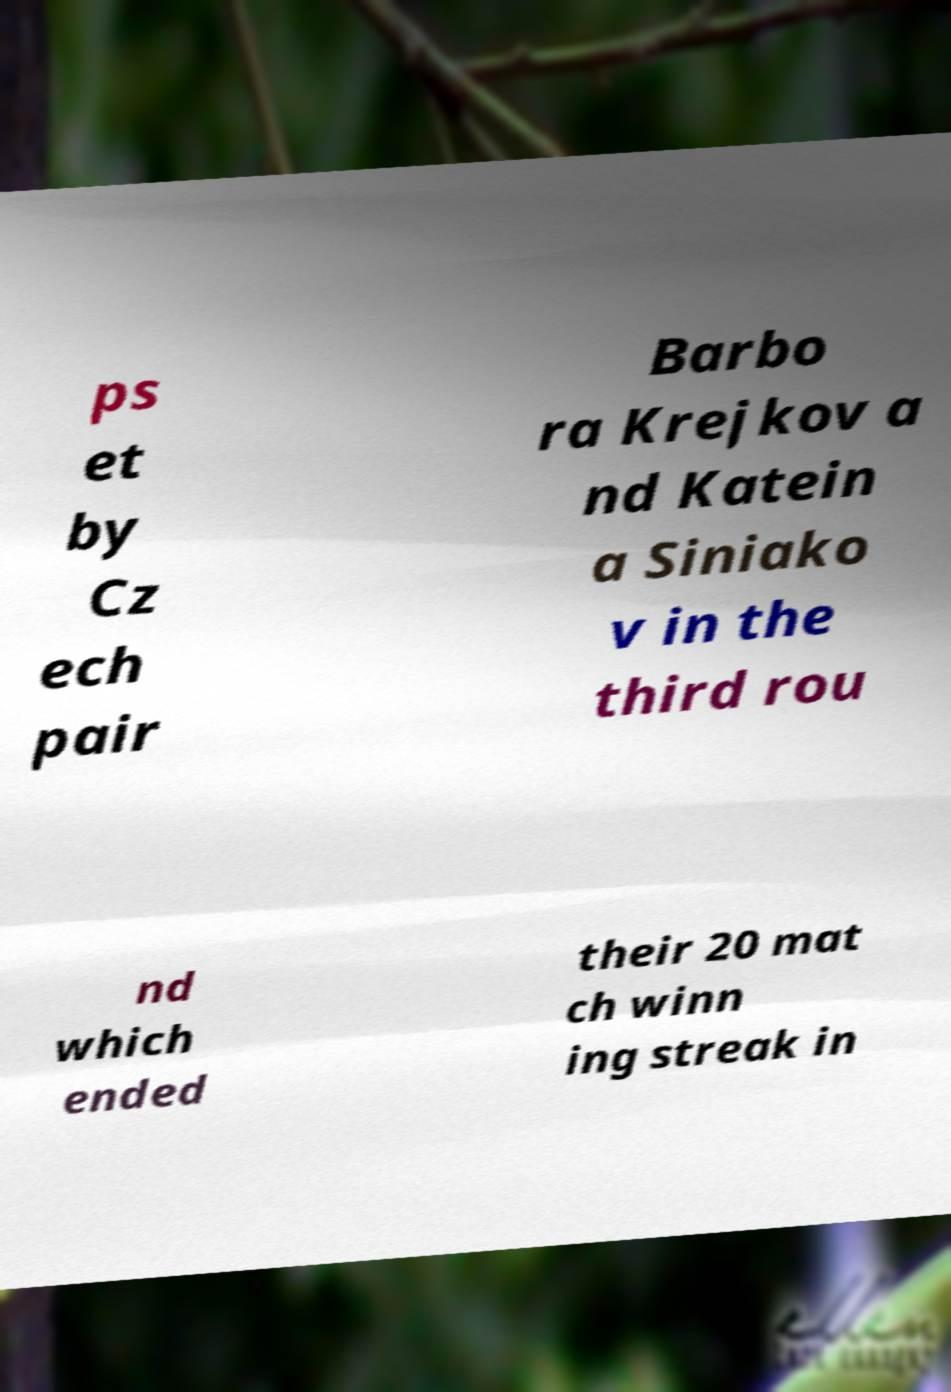Can you accurately transcribe the text from the provided image for me? ps et by Cz ech pair Barbo ra Krejkov a nd Katein a Siniako v in the third rou nd which ended their 20 mat ch winn ing streak in 